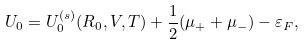Convert formula to latex. <formula><loc_0><loc_0><loc_500><loc_500>U _ { 0 } = U _ { 0 } ^ { ( s ) } ( R _ { 0 } , V , T ) + \frac { 1 } { 2 } ( \mu _ { + } + \mu _ { - } ) - \varepsilon _ { F } ,</formula> 